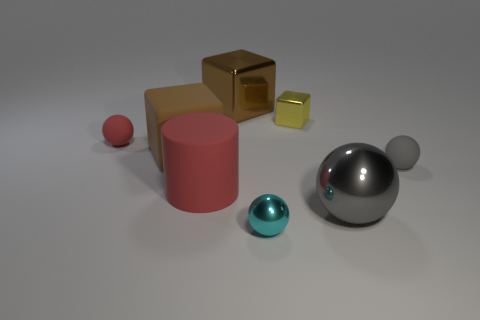What number of things are tiny metal spheres or cubes? There are a total of four objects that appear to be tiny and metallic in nature; three of them are spherical, and one is a cube. 